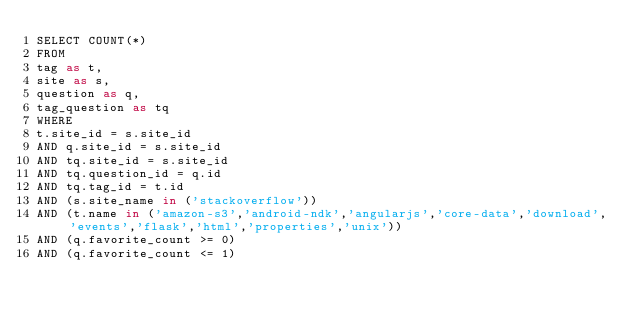<code> <loc_0><loc_0><loc_500><loc_500><_SQL_>SELECT COUNT(*)
FROM
tag as t,
site as s,
question as q,
tag_question as tq
WHERE
t.site_id = s.site_id
AND q.site_id = s.site_id
AND tq.site_id = s.site_id
AND tq.question_id = q.id
AND tq.tag_id = t.id
AND (s.site_name in ('stackoverflow'))
AND (t.name in ('amazon-s3','android-ndk','angularjs','core-data','download','events','flask','html','properties','unix'))
AND (q.favorite_count >= 0)
AND (q.favorite_count <= 1)
</code> 